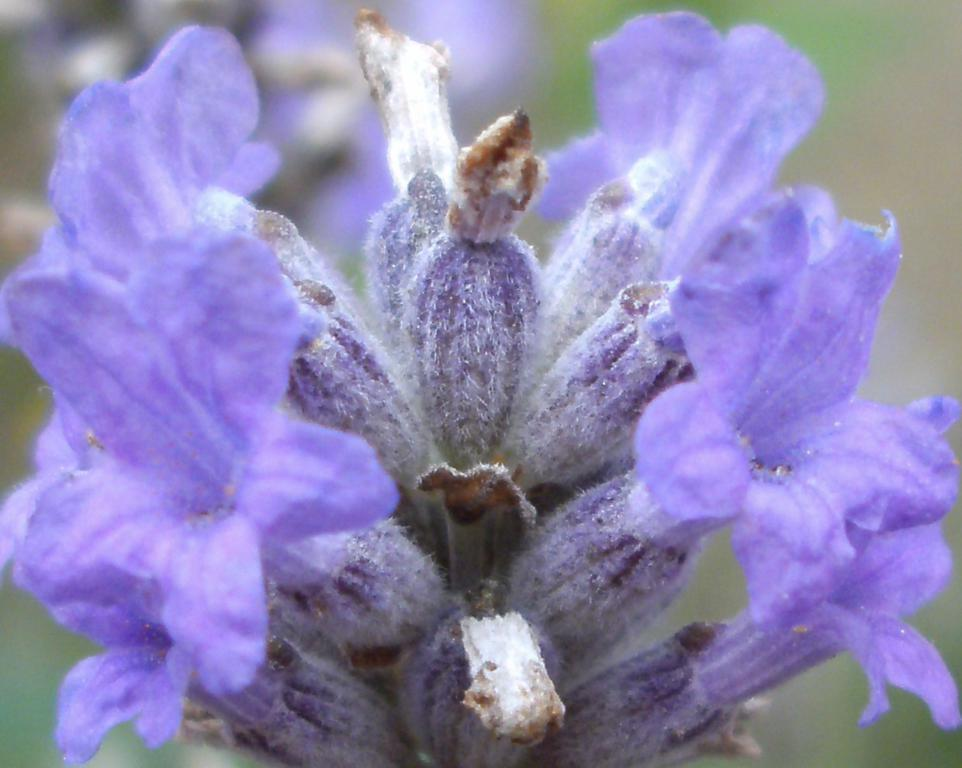What is the main subject of the image? There is a bunch of flowers in the image. What color are the flowers? The flowers are purple in color. Can you describe the background of the image? The background of the image appears blurry. How many girls are on the team in the image? There are no girls or teams present in the image; it features a bunch of purple flowers with a blurry background. 